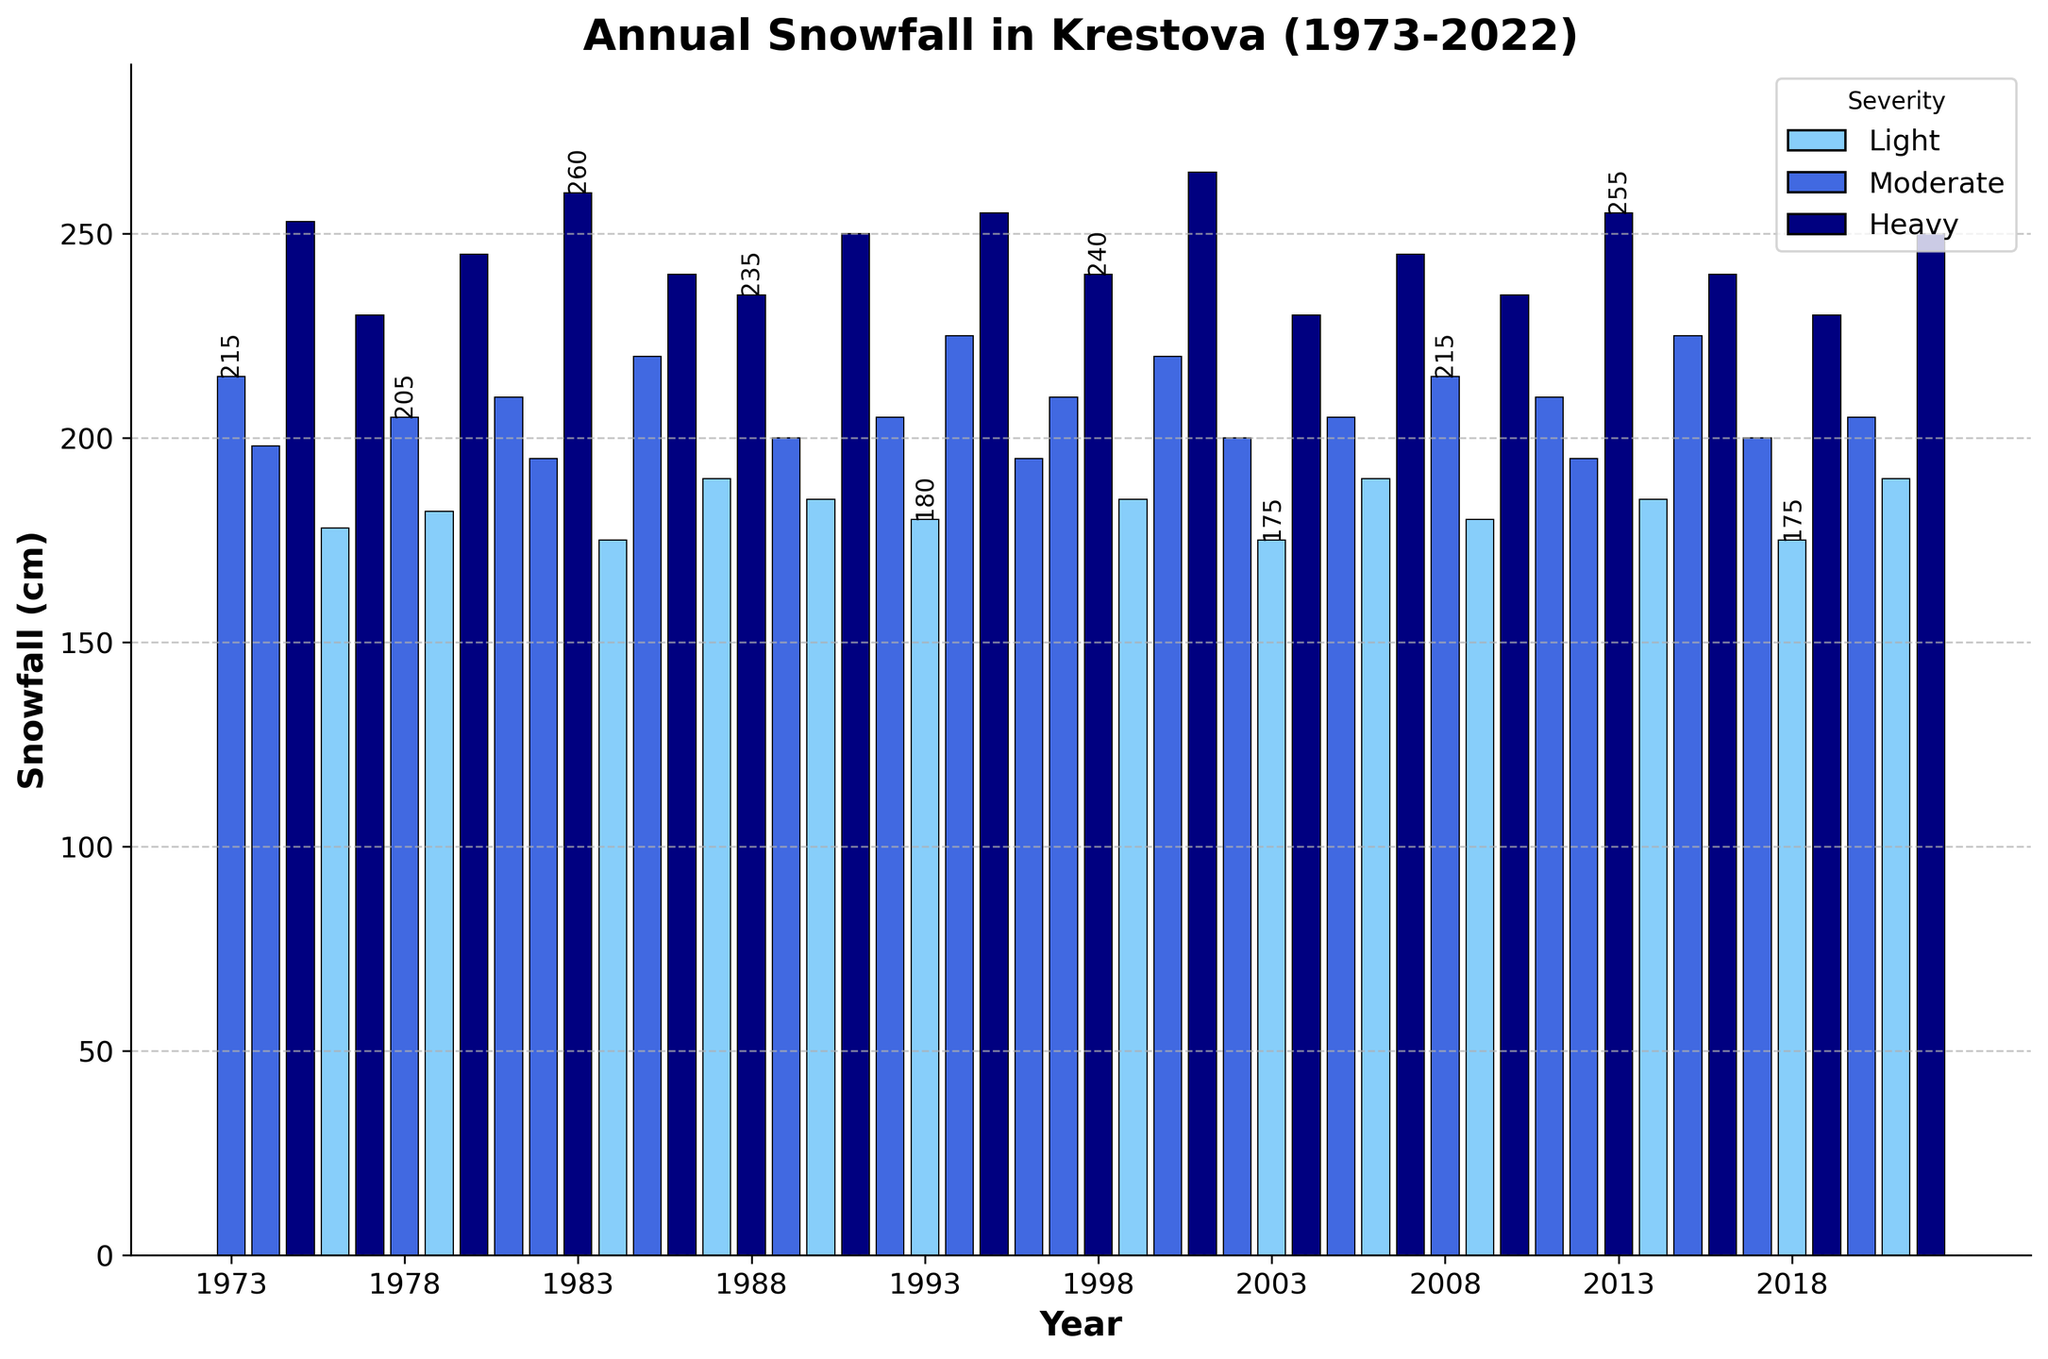what is the total snowfall in the last 5 years? Sum the snowfall amounts for the years 2018 to 2022 (175 + 230 + 205 + 190 + 250)
Answer: 1050 cm In which year was the snowfall highest? Find the highest bar in the plot and note the corresponding year. The tallest bar corresponds to the year with the highest snowfall, which is in 2001 with 265 cm of snowfall
Answer: 2001 Which severity category has the most occurrences? Count the number of bars in each color category. Compare the counts for Light, Moderate, and Heavy. Moderate appears most frequently.
Answer: Moderate How many years have had heavy snowfall? Count the number of bars that are colored to indicate heavy snowfall.
Answer: 13 What is the average snowfall amount for moderate years? Sum the snowfall amounts for moderate years and divide by the number of moderate years: (198+215+205+195+210+220+200+205+195+210+200+225+210+205) / 14 = 204.64
Answer: 204.64 cm In which year or years was the snowfall equal to 240 cm? Check the heights of the bars to find those equal to 240 cm and note their corresponding years.
Answer: 1986, 1998, 2016 What's the difference in snowfall between the year with the highest snowfall and the year with the lowest? Subtract the smallest bar height from the tallest bar height (265 - 175).
Answer: 90 cm Does any year show a change in snowfall severity from the previous year? Analyze consecutive years to see changes in bar colors, especially between different colors representing different severities. For example, 1974 (Moderate) to 1975 (Heavy) shows a change.
Answer: Yes Which year had the lightest snowfall and what was the amount? Identify the shortest bar and the corresponding year, which is 1984 with 175 cm of snowfall.
Answer: 1984, 175 cm Compare the average snowfall over the first 25 years and the last 25 years. Which period had more snowfall? Calculate the average for the first 25 years and the last 25 years separately, and then compare the values. (First 25 years Sum: 2015 / 25 = 201.80 and Last 25 years Sum: 5235 / 25 = 209.40)
Answer: Last 25 years, 209.40 cm 